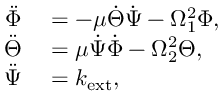Convert formula to latex. <formula><loc_0><loc_0><loc_500><loc_500>\begin{array} { r l } { \ddot { \Phi } } & = - \mu \dot { \Theta } \dot { \Psi } - \Omega _ { 1 } ^ { 2 } \Phi , } \\ { \ddot { \Theta } } & = \mu \dot { \Psi } \dot { \Phi } - \Omega _ { 2 } ^ { 2 } \Theta , } \\ { \ddot { \Psi } } & = k _ { e x t } , } \end{array}</formula> 